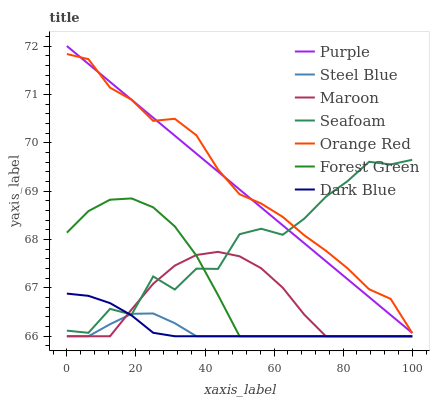Does Steel Blue have the minimum area under the curve?
Answer yes or no. Yes. Does Orange Red have the maximum area under the curve?
Answer yes or no. Yes. Does Maroon have the minimum area under the curve?
Answer yes or no. No. Does Maroon have the maximum area under the curve?
Answer yes or no. No. Is Purple the smoothest?
Answer yes or no. Yes. Is Seafoam the roughest?
Answer yes or no. Yes. Is Steel Blue the smoothest?
Answer yes or no. No. Is Steel Blue the roughest?
Answer yes or no. No. Does Steel Blue have the lowest value?
Answer yes or no. Yes. Does Seafoam have the lowest value?
Answer yes or no. No. Does Purple have the highest value?
Answer yes or no. Yes. Does Maroon have the highest value?
Answer yes or no. No. Is Steel Blue less than Orange Red?
Answer yes or no. Yes. Is Purple greater than Steel Blue?
Answer yes or no. Yes. Does Dark Blue intersect Seafoam?
Answer yes or no. Yes. Is Dark Blue less than Seafoam?
Answer yes or no. No. Is Dark Blue greater than Seafoam?
Answer yes or no. No. Does Steel Blue intersect Orange Red?
Answer yes or no. No. 